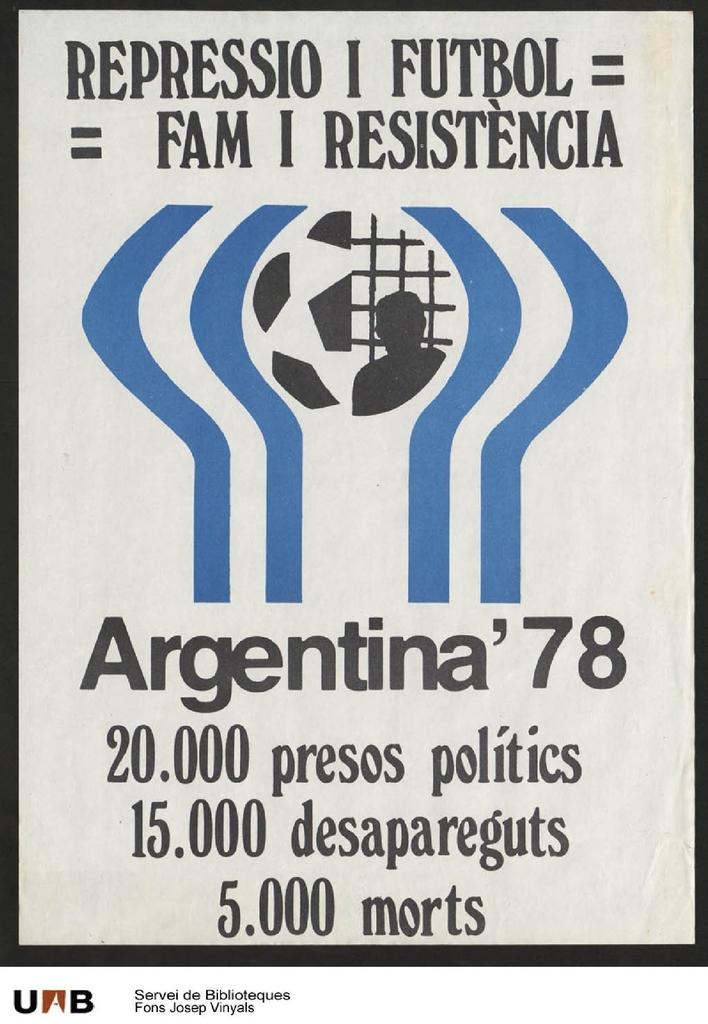What language is that?
Make the answer very short. Spanish. What country is on this poster?
Your answer should be compact. Argentina. 